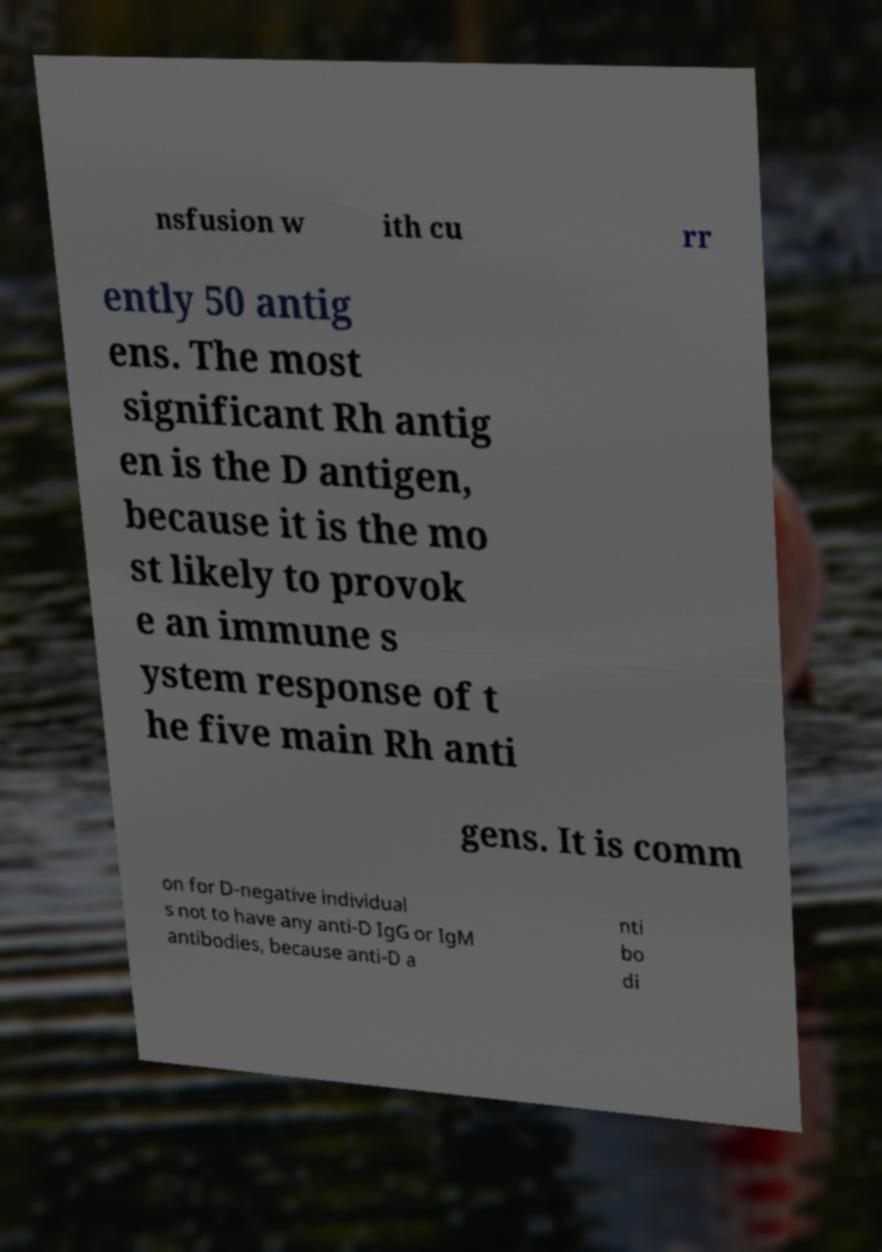What messages or text are displayed in this image? I need them in a readable, typed format. nsfusion w ith cu rr ently 50 antig ens. The most significant Rh antig en is the D antigen, because it is the mo st likely to provok e an immune s ystem response of t he five main Rh anti gens. It is comm on for D-negative individual s not to have any anti-D IgG or IgM antibodies, because anti-D a nti bo di 